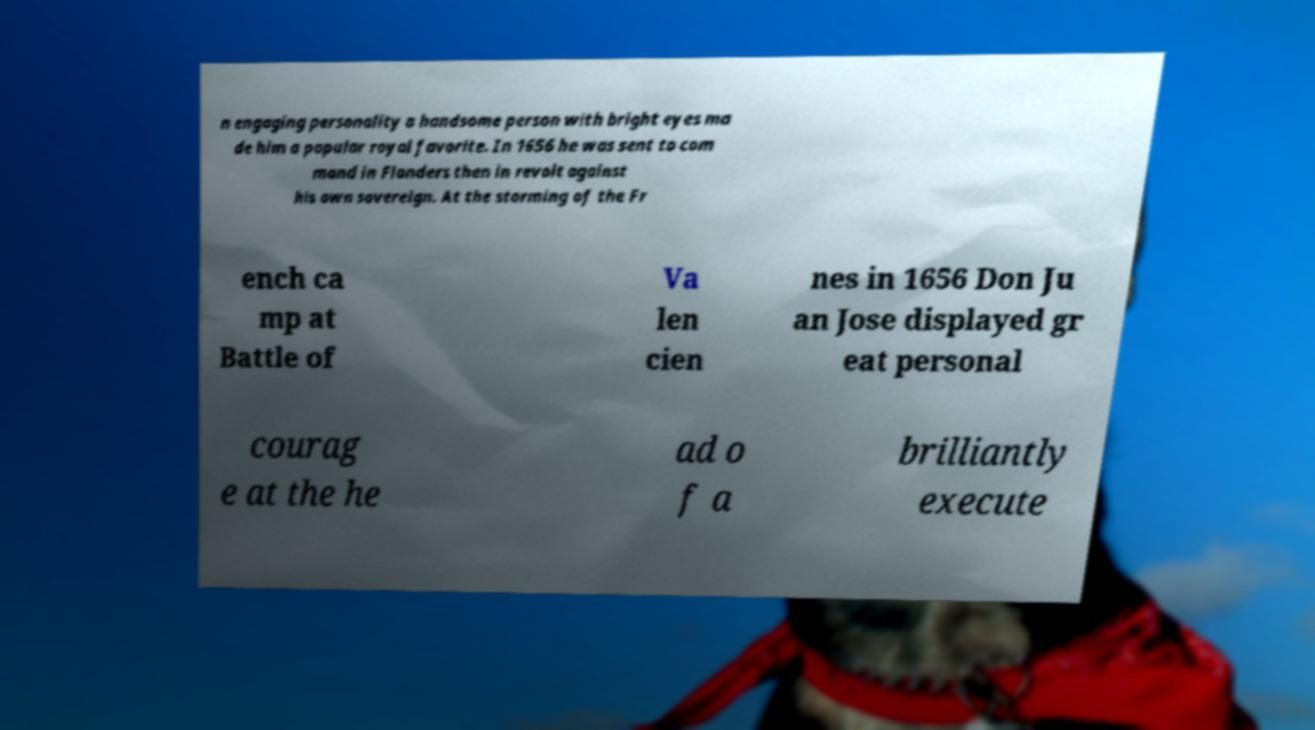I need the written content from this picture converted into text. Can you do that? n engaging personality a handsome person with bright eyes ma de him a popular royal favorite. In 1656 he was sent to com mand in Flanders then in revolt against his own sovereign. At the storming of the Fr ench ca mp at Battle of Va len cien nes in 1656 Don Ju an Jose displayed gr eat personal courag e at the he ad o f a brilliantly execute 